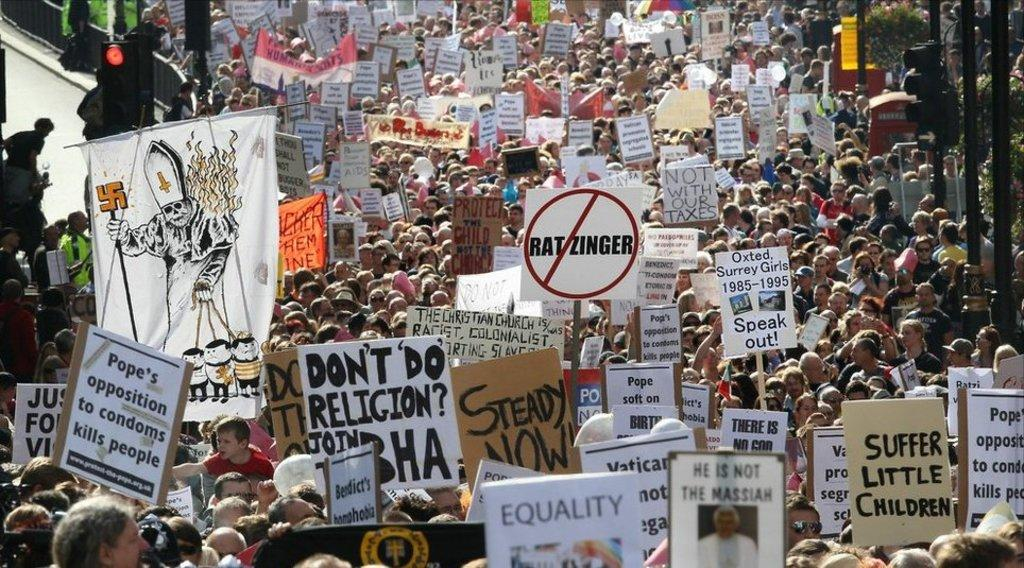What is the main subject of the image? The main subject of the image is a group of people. What are some of the people in the group doing? Some people in the group are holding boards. What can be seen on the boards that the people are holding? The boards have writing on them. Can you tell me what type of eggnog is being served at the beach in the image? There is no eggnog or beach present in the image; it features a group of people holding boards with writing on them. Is there a dog visible in the image? There is no dog present in the image. 